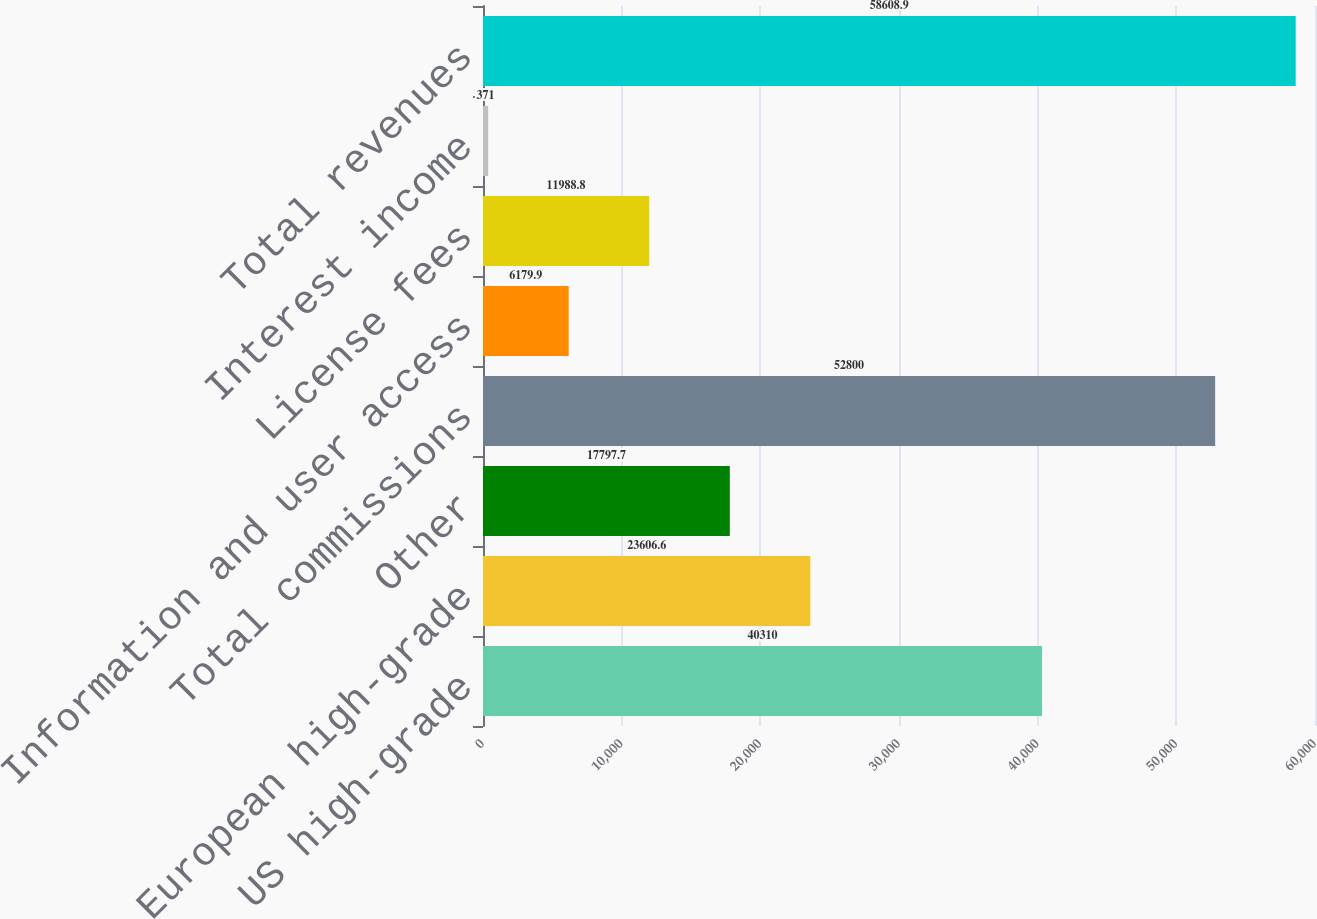<chart> <loc_0><loc_0><loc_500><loc_500><bar_chart><fcel>US high-grade<fcel>European high-grade<fcel>Other<fcel>Total commissions<fcel>Information and user access<fcel>License fees<fcel>Interest income<fcel>Total revenues<nl><fcel>40310<fcel>23606.6<fcel>17797.7<fcel>52800<fcel>6179.9<fcel>11988.8<fcel>371<fcel>58608.9<nl></chart> 